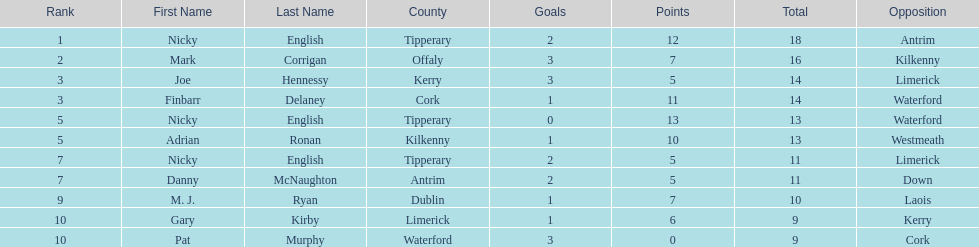What is the first name on the list? Nicky English. 